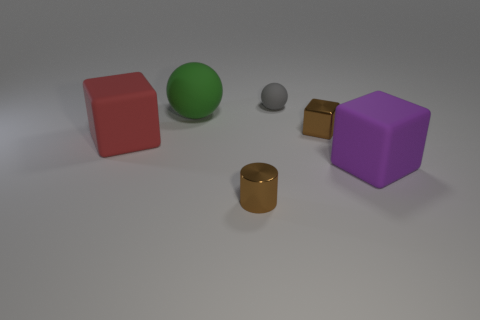Subtract all rubber blocks. How many blocks are left? 1 Subtract all cylinders. How many objects are left? 5 Subtract all gray balls. How many balls are left? 1 Add 1 small gray matte blocks. How many small gray matte blocks exist? 1 Add 2 small brown cylinders. How many objects exist? 8 Subtract 0 purple cylinders. How many objects are left? 6 Subtract 2 spheres. How many spheres are left? 0 Subtract all green cubes. Subtract all blue balls. How many cubes are left? 3 Subtract all cyan cylinders. How many gray balls are left? 1 Subtract all big purple blocks. Subtract all red cubes. How many objects are left? 4 